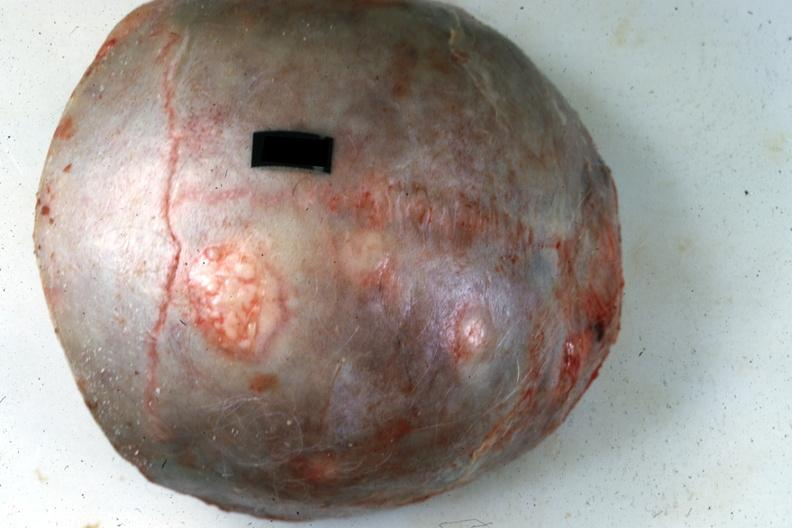what is present?
Answer the question using a single word or phrase. Multiple myeloma 